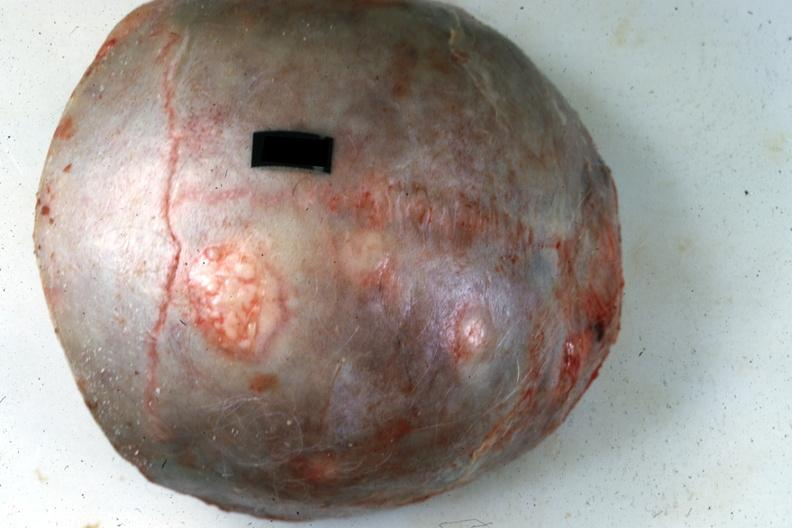what is present?
Answer the question using a single word or phrase. Multiple myeloma 